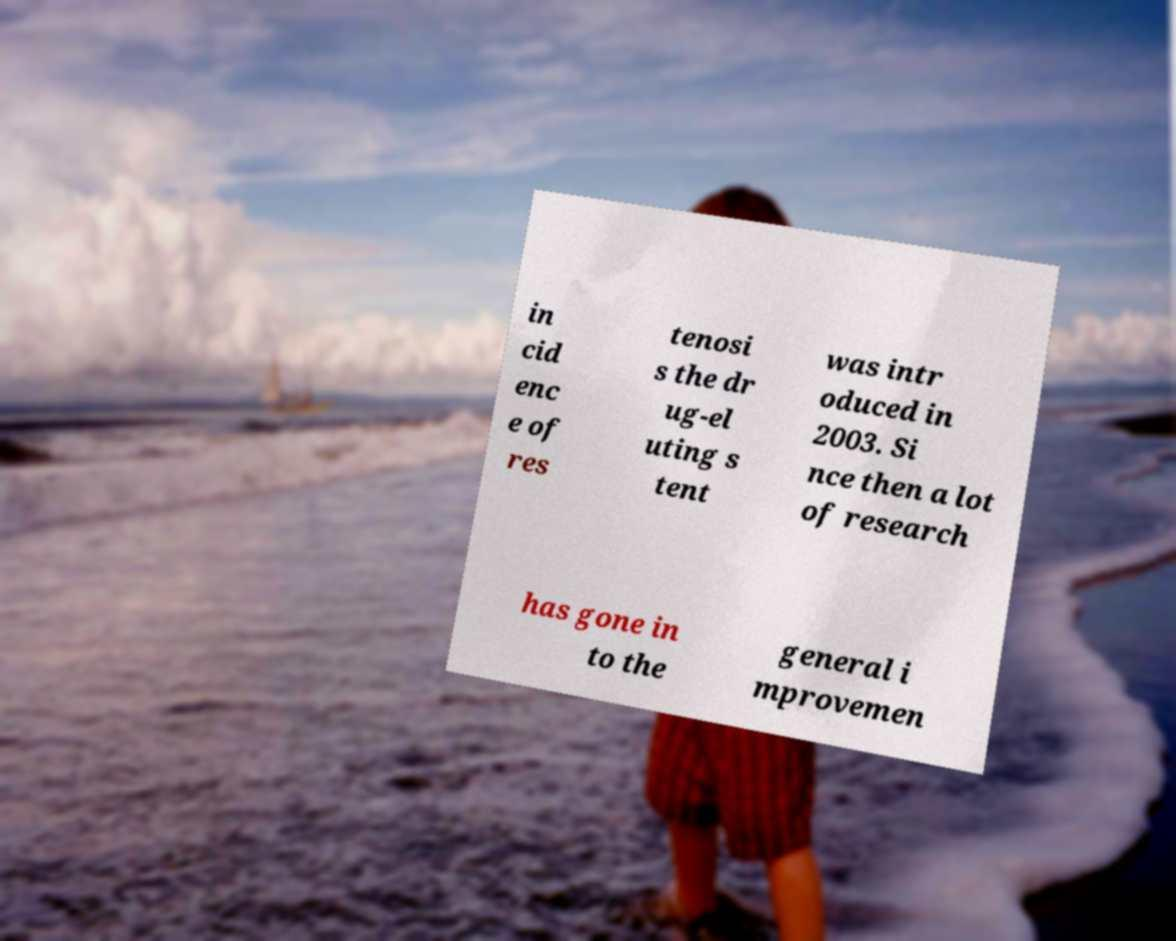What messages or text are displayed in this image? I need them in a readable, typed format. in cid enc e of res tenosi s the dr ug-el uting s tent was intr oduced in 2003. Si nce then a lot of research has gone in to the general i mprovemen 